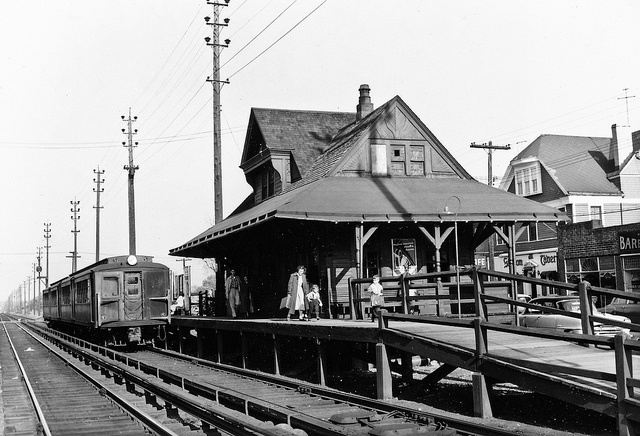Describe the objects in this image and their specific colors. I can see train in white, gray, black, darkgray, and lightgray tones, car in white, black, gray, darkgray, and lightgray tones, people in white, darkgray, gray, lightgray, and black tones, people in white, gray, and black tones, and car in white, gray, black, and lightgray tones in this image. 